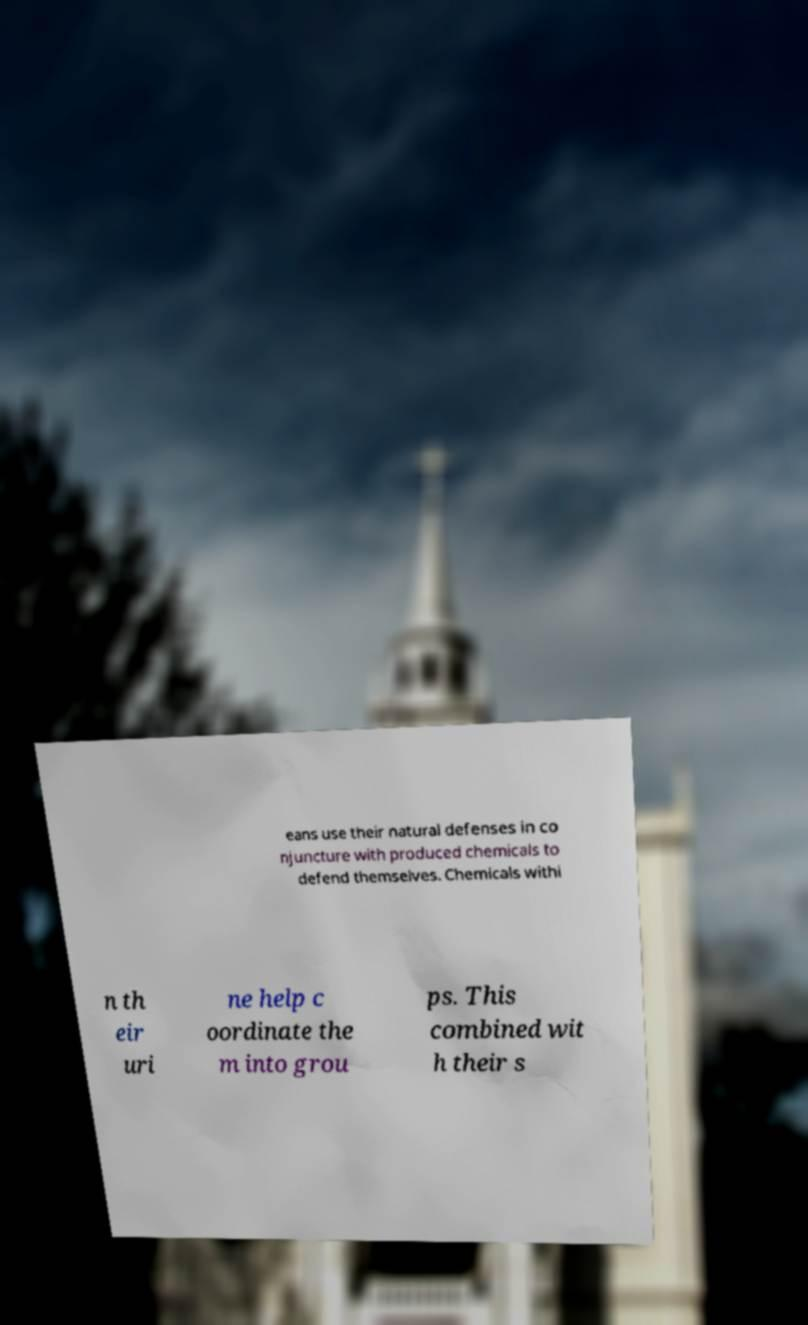Could you assist in decoding the text presented in this image and type it out clearly? eans use their natural defenses in co njuncture with produced chemicals to defend themselves. Chemicals withi n th eir uri ne help c oordinate the m into grou ps. This combined wit h their s 